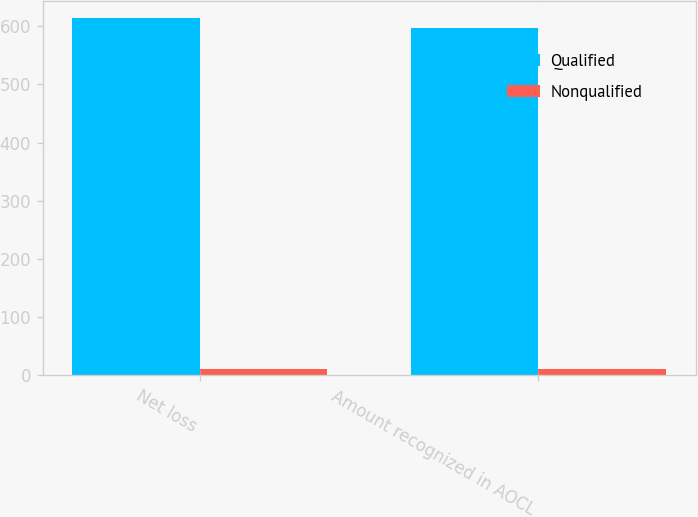Convert chart to OTSL. <chart><loc_0><loc_0><loc_500><loc_500><stacked_bar_chart><ecel><fcel>Net loss<fcel>Amount recognized in AOCL<nl><fcel>Qualified<fcel>613.2<fcel>597.5<nl><fcel>Nonqualified<fcel>11.5<fcel>11.5<nl></chart> 